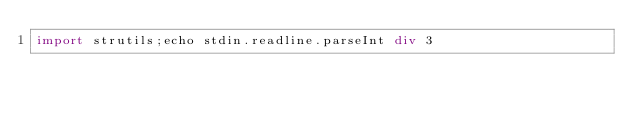<code> <loc_0><loc_0><loc_500><loc_500><_Nim_>import strutils;echo stdin.readline.parseInt div 3</code> 